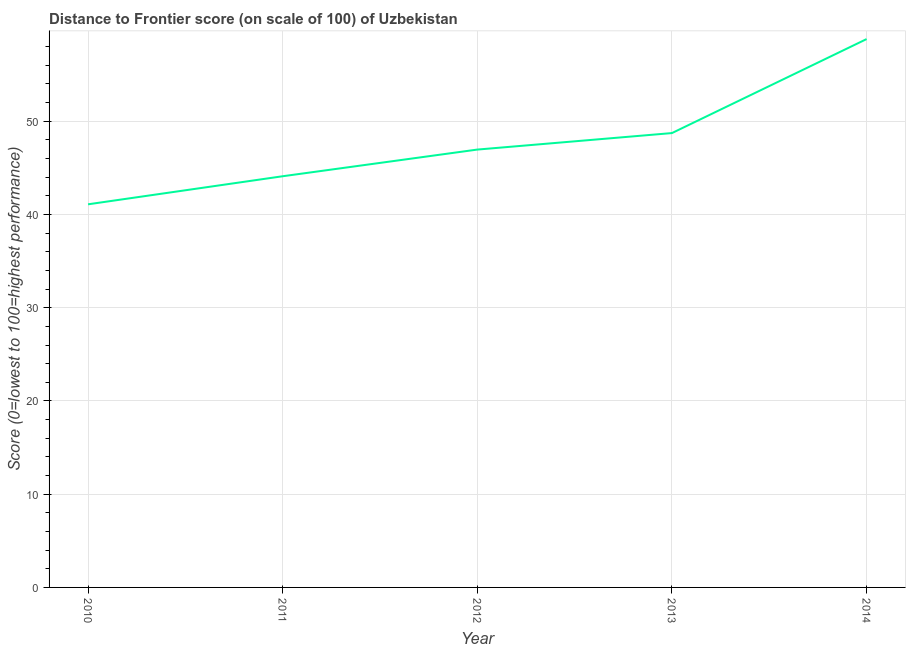What is the distance to frontier score in 2012?
Ensure brevity in your answer.  46.96. Across all years, what is the maximum distance to frontier score?
Ensure brevity in your answer.  58.81. Across all years, what is the minimum distance to frontier score?
Your answer should be compact. 41.09. In which year was the distance to frontier score minimum?
Your answer should be compact. 2010. What is the sum of the distance to frontier score?
Offer a terse response. 239.69. What is the difference between the distance to frontier score in 2010 and 2012?
Provide a succinct answer. -5.87. What is the average distance to frontier score per year?
Give a very brief answer. 47.94. What is the median distance to frontier score?
Give a very brief answer. 46.96. What is the ratio of the distance to frontier score in 2011 to that in 2014?
Offer a terse response. 0.75. Is the distance to frontier score in 2010 less than that in 2013?
Make the answer very short. Yes. What is the difference between the highest and the second highest distance to frontier score?
Give a very brief answer. 10.08. What is the difference between the highest and the lowest distance to frontier score?
Your answer should be compact. 17.72. In how many years, is the distance to frontier score greater than the average distance to frontier score taken over all years?
Your answer should be compact. 2. Does the distance to frontier score monotonically increase over the years?
Offer a terse response. Yes. How many lines are there?
Keep it short and to the point. 1. How many years are there in the graph?
Make the answer very short. 5. What is the difference between two consecutive major ticks on the Y-axis?
Your response must be concise. 10. Are the values on the major ticks of Y-axis written in scientific E-notation?
Offer a very short reply. No. Does the graph contain any zero values?
Your response must be concise. No. What is the title of the graph?
Ensure brevity in your answer.  Distance to Frontier score (on scale of 100) of Uzbekistan. What is the label or title of the Y-axis?
Offer a terse response. Score (0=lowest to 100=highest performance). What is the Score (0=lowest to 100=highest performance) in 2010?
Give a very brief answer. 41.09. What is the Score (0=lowest to 100=highest performance) in 2011?
Make the answer very short. 44.1. What is the Score (0=lowest to 100=highest performance) of 2012?
Offer a terse response. 46.96. What is the Score (0=lowest to 100=highest performance) in 2013?
Provide a short and direct response. 48.73. What is the Score (0=lowest to 100=highest performance) of 2014?
Ensure brevity in your answer.  58.81. What is the difference between the Score (0=lowest to 100=highest performance) in 2010 and 2011?
Keep it short and to the point. -3.01. What is the difference between the Score (0=lowest to 100=highest performance) in 2010 and 2012?
Your answer should be compact. -5.87. What is the difference between the Score (0=lowest to 100=highest performance) in 2010 and 2013?
Keep it short and to the point. -7.64. What is the difference between the Score (0=lowest to 100=highest performance) in 2010 and 2014?
Your answer should be very brief. -17.72. What is the difference between the Score (0=lowest to 100=highest performance) in 2011 and 2012?
Offer a very short reply. -2.86. What is the difference between the Score (0=lowest to 100=highest performance) in 2011 and 2013?
Your answer should be compact. -4.63. What is the difference between the Score (0=lowest to 100=highest performance) in 2011 and 2014?
Make the answer very short. -14.71. What is the difference between the Score (0=lowest to 100=highest performance) in 2012 and 2013?
Ensure brevity in your answer.  -1.77. What is the difference between the Score (0=lowest to 100=highest performance) in 2012 and 2014?
Provide a succinct answer. -11.85. What is the difference between the Score (0=lowest to 100=highest performance) in 2013 and 2014?
Your answer should be compact. -10.08. What is the ratio of the Score (0=lowest to 100=highest performance) in 2010 to that in 2011?
Your response must be concise. 0.93. What is the ratio of the Score (0=lowest to 100=highest performance) in 2010 to that in 2013?
Provide a succinct answer. 0.84. What is the ratio of the Score (0=lowest to 100=highest performance) in 2010 to that in 2014?
Ensure brevity in your answer.  0.7. What is the ratio of the Score (0=lowest to 100=highest performance) in 2011 to that in 2012?
Your response must be concise. 0.94. What is the ratio of the Score (0=lowest to 100=highest performance) in 2011 to that in 2013?
Offer a terse response. 0.91. What is the ratio of the Score (0=lowest to 100=highest performance) in 2012 to that in 2013?
Provide a short and direct response. 0.96. What is the ratio of the Score (0=lowest to 100=highest performance) in 2012 to that in 2014?
Provide a short and direct response. 0.8. What is the ratio of the Score (0=lowest to 100=highest performance) in 2013 to that in 2014?
Offer a very short reply. 0.83. 